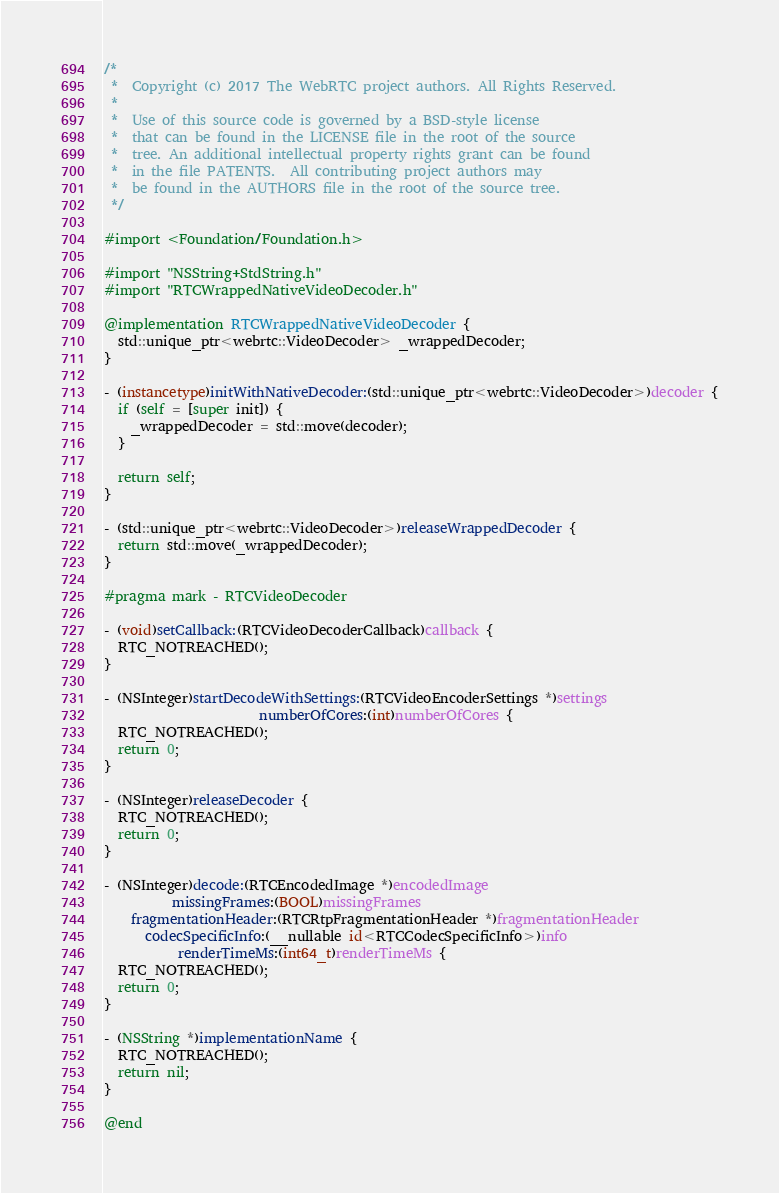<code> <loc_0><loc_0><loc_500><loc_500><_ObjectiveC_>/*
 *  Copyright (c) 2017 The WebRTC project authors. All Rights Reserved.
 *
 *  Use of this source code is governed by a BSD-style license
 *  that can be found in the LICENSE file in the root of the source
 *  tree. An additional intellectual property rights grant can be found
 *  in the file PATENTS.  All contributing project authors may
 *  be found in the AUTHORS file in the root of the source tree.
 */

#import <Foundation/Foundation.h>

#import "NSString+StdString.h"
#import "RTCWrappedNativeVideoDecoder.h"

@implementation RTCWrappedNativeVideoDecoder {
  std::unique_ptr<webrtc::VideoDecoder> _wrappedDecoder;
}

- (instancetype)initWithNativeDecoder:(std::unique_ptr<webrtc::VideoDecoder>)decoder {
  if (self = [super init]) {
    _wrappedDecoder = std::move(decoder);
  }

  return self;
}

- (std::unique_ptr<webrtc::VideoDecoder>)releaseWrappedDecoder {
  return std::move(_wrappedDecoder);
}

#pragma mark - RTCVideoDecoder

- (void)setCallback:(RTCVideoDecoderCallback)callback {
  RTC_NOTREACHED();
}

- (NSInteger)startDecodeWithSettings:(RTCVideoEncoderSettings *)settings
                       numberOfCores:(int)numberOfCores {
  RTC_NOTREACHED();
  return 0;
}

- (NSInteger)releaseDecoder {
  RTC_NOTREACHED();
  return 0;
}

- (NSInteger)decode:(RTCEncodedImage *)encodedImage
          missingFrames:(BOOL)missingFrames
    fragmentationHeader:(RTCRtpFragmentationHeader *)fragmentationHeader
      codecSpecificInfo:(__nullable id<RTCCodecSpecificInfo>)info
           renderTimeMs:(int64_t)renderTimeMs {
  RTC_NOTREACHED();
  return 0;
}

- (NSString *)implementationName {
  RTC_NOTREACHED();
  return nil;
}

@end
</code> 